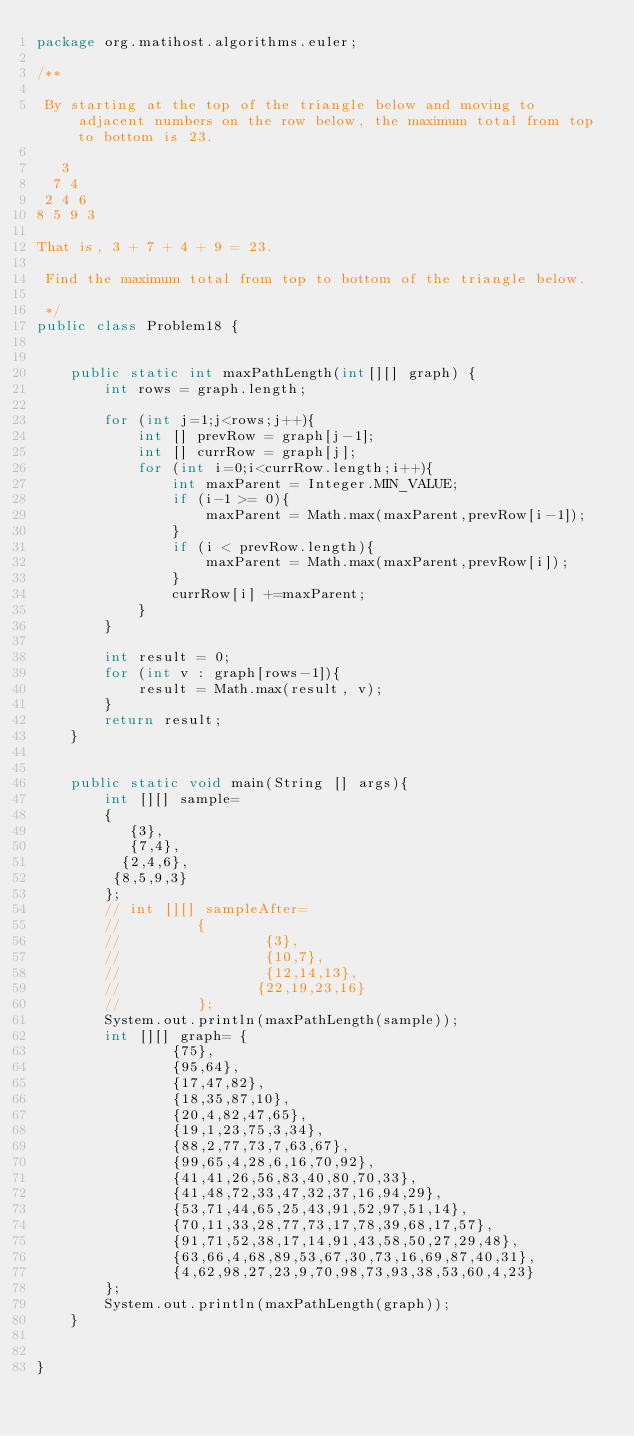Convert code to text. <code><loc_0><loc_0><loc_500><loc_500><_Java_>package org.matihost.algorithms.euler;

/**

 By starting at the top of the triangle below and moving to adjacent numbers on the row below, the maximum total from top to bottom is 23.

   3
  7 4
 2 4 6
8 5 9 3

That is, 3 + 7 + 4 + 9 = 23.

 Find the maximum total from top to bottom of the triangle below.

 */
public class Problem18 {


    public static int maxPathLength(int[][] graph) {
        int rows = graph.length;

        for (int j=1;j<rows;j++){
            int [] prevRow = graph[j-1];
            int [] currRow = graph[j];
            for (int i=0;i<currRow.length;i++){
                int maxParent = Integer.MIN_VALUE;
                if (i-1 >= 0){
                    maxParent = Math.max(maxParent,prevRow[i-1]);
                }
                if (i < prevRow.length){
                    maxParent = Math.max(maxParent,prevRow[i]);
                }
                currRow[i] +=maxParent;
            }
        }

        int result = 0;
        for (int v : graph[rows-1]){
            result = Math.max(result, v);
        }
        return result;
    }


    public static void main(String [] args){
        int [][] sample=
        {
           {3},
           {7,4},
          {2,4,6},
         {8,5,9,3}
        };
        // int [][] sampleAfter=
        //         {
        //                 {3},
        //                 {10,7},
        //                 {12,14,13},
        //                {22,19,23,16}
        //         };
        System.out.println(maxPathLength(sample));
        int [][] graph= {
                {75},
                {95,64},
                {17,47,82},
                {18,35,87,10},
                {20,4,82,47,65},
                {19,1,23,75,3,34},
                {88,2,77,73,7,63,67},
                {99,65,4,28,6,16,70,92},
                {41,41,26,56,83,40,80,70,33},
                {41,48,72,33,47,32,37,16,94,29},
                {53,71,44,65,25,43,91,52,97,51,14},
                {70,11,33,28,77,73,17,78,39,68,17,57},
                {91,71,52,38,17,14,91,43,58,50,27,29,48},
                {63,66,4,68,89,53,67,30,73,16,69,87,40,31},
                {4,62,98,27,23,9,70,98,73,93,38,53,60,4,23}
        };
        System.out.println(maxPathLength(graph));
    }


}
</code> 